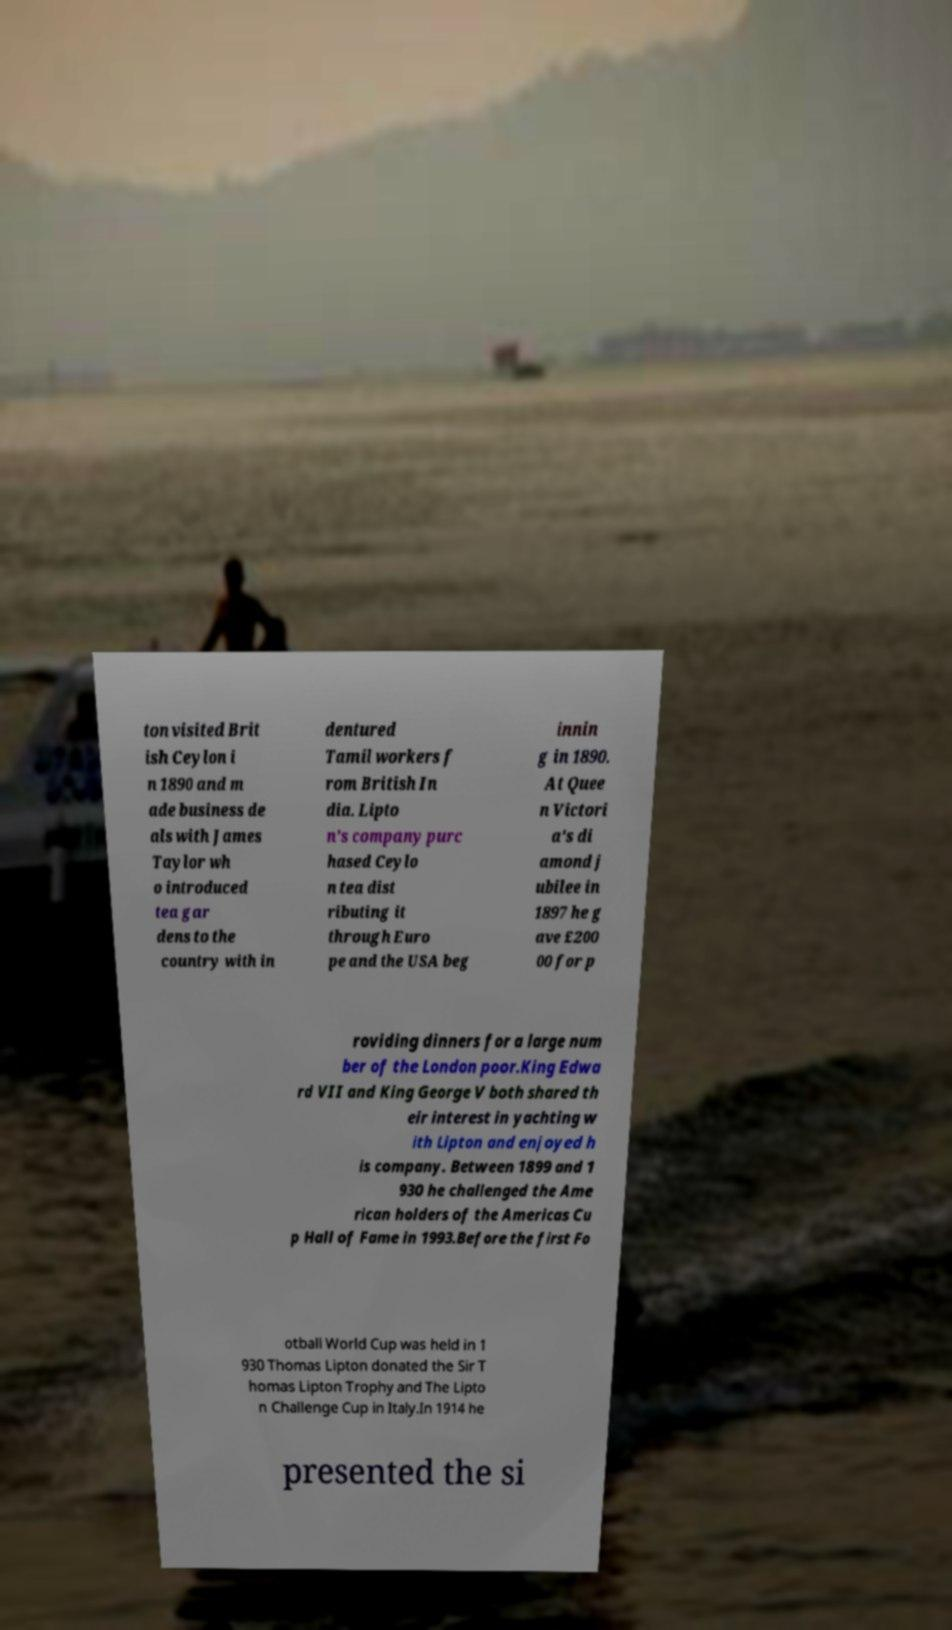I need the written content from this picture converted into text. Can you do that? ton visited Brit ish Ceylon i n 1890 and m ade business de als with James Taylor wh o introduced tea gar dens to the country with in dentured Tamil workers f rom British In dia. Lipto n's company purc hased Ceylo n tea dist ributing it through Euro pe and the USA beg innin g in 1890. At Quee n Victori a's di amond j ubilee in 1897 he g ave £200 00 for p roviding dinners for a large num ber of the London poor.King Edwa rd VII and King George V both shared th eir interest in yachting w ith Lipton and enjoyed h is company. Between 1899 and 1 930 he challenged the Ame rican holders of the Americas Cu p Hall of Fame in 1993.Before the first Fo otball World Cup was held in 1 930 Thomas Lipton donated the Sir T homas Lipton Trophy and The Lipto n Challenge Cup in Italy.In 1914 he presented the si 